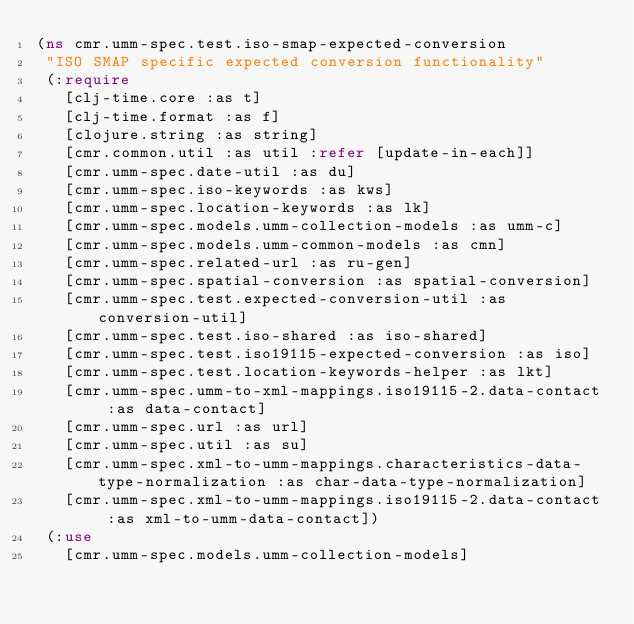<code> <loc_0><loc_0><loc_500><loc_500><_Clojure_>(ns cmr.umm-spec.test.iso-smap-expected-conversion
 "ISO SMAP specific expected conversion functionality"
 (:require
   [clj-time.core :as t]
   [clj-time.format :as f]
   [clojure.string :as string]
   [cmr.common.util :as util :refer [update-in-each]]
   [cmr.umm-spec.date-util :as du]
   [cmr.umm-spec.iso-keywords :as kws]
   [cmr.umm-spec.location-keywords :as lk]
   [cmr.umm-spec.models.umm-collection-models :as umm-c]
   [cmr.umm-spec.models.umm-common-models :as cmn]
   [cmr.umm-spec.related-url :as ru-gen]
   [cmr.umm-spec.spatial-conversion :as spatial-conversion]
   [cmr.umm-spec.test.expected-conversion-util :as conversion-util]
   [cmr.umm-spec.test.iso-shared :as iso-shared]
   [cmr.umm-spec.test.iso19115-expected-conversion :as iso]
   [cmr.umm-spec.test.location-keywords-helper :as lkt]
   [cmr.umm-spec.umm-to-xml-mappings.iso19115-2.data-contact :as data-contact]
   [cmr.umm-spec.url :as url]
   [cmr.umm-spec.util :as su]
   [cmr.umm-spec.xml-to-umm-mappings.characteristics-data-type-normalization :as char-data-type-normalization]
   [cmr.umm-spec.xml-to-umm-mappings.iso19115-2.data-contact :as xml-to-umm-data-contact])
 (:use
   [cmr.umm-spec.models.umm-collection-models]</code> 